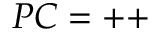<formula> <loc_0><loc_0><loc_500><loc_500>P C = + +</formula> 